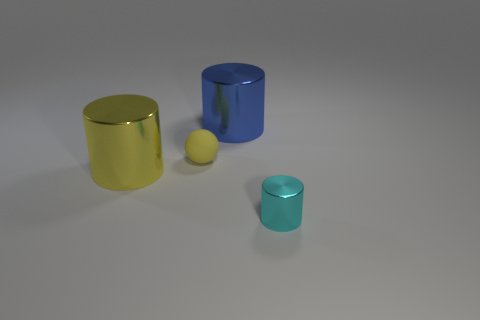Add 4 large blue metal cylinders. How many objects exist? 8 Subtract all cylinders. How many objects are left? 1 Add 2 matte spheres. How many matte spheres exist? 3 Subtract 0 red cylinders. How many objects are left? 4 Subtract all tiny yellow things. Subtract all small cyan metal objects. How many objects are left? 2 Add 4 yellow things. How many yellow things are left? 6 